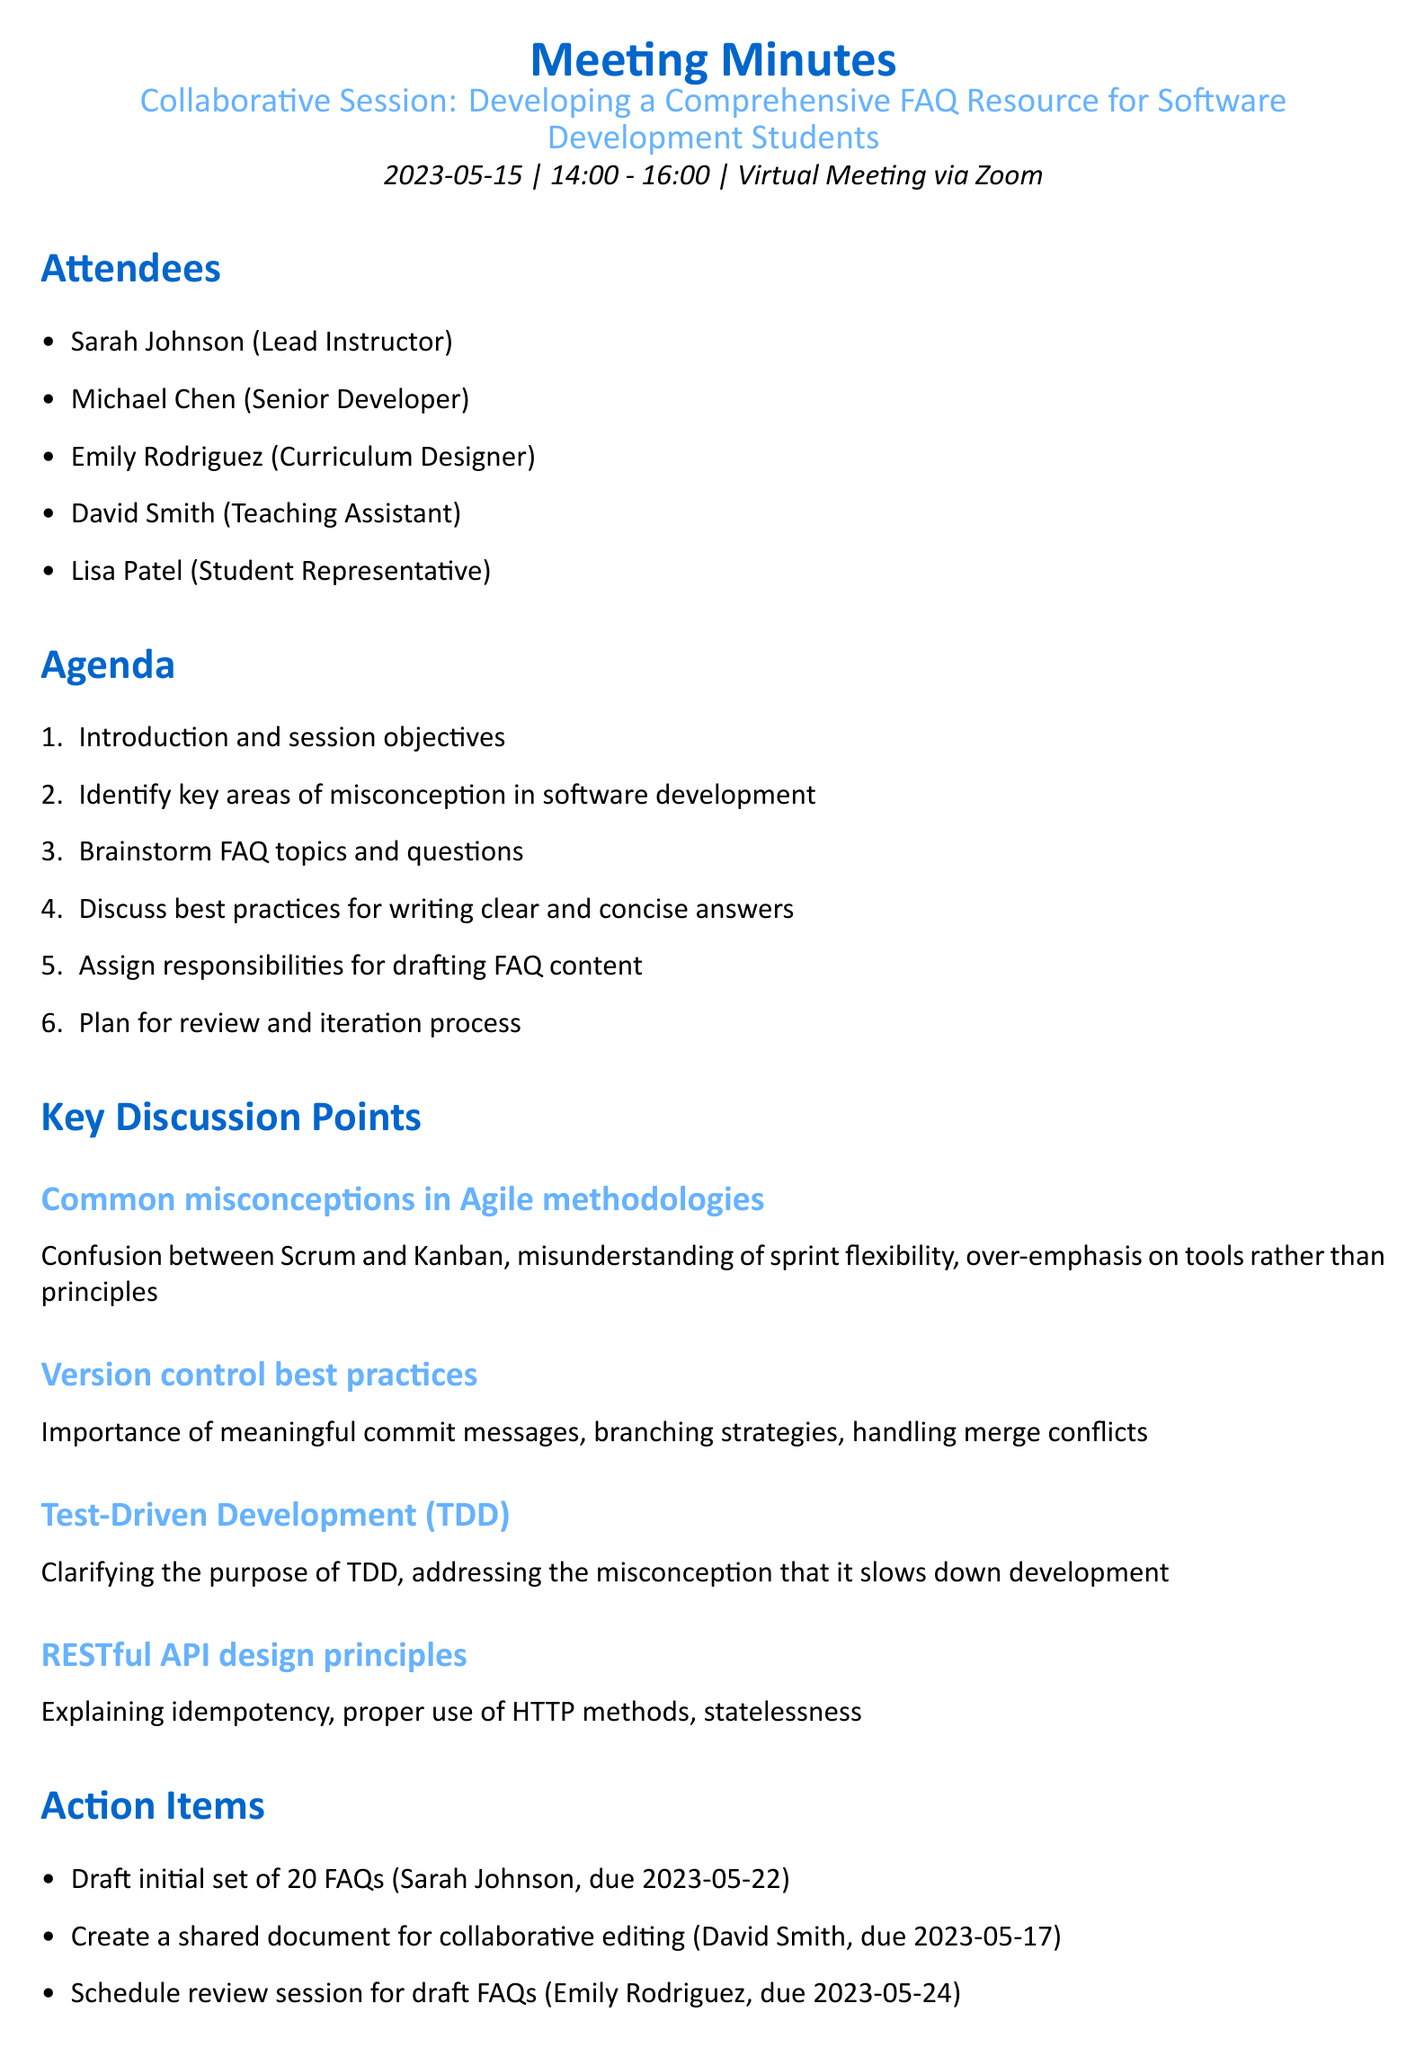What is the date of the meeting? The date of the meeting is specified in the meeting details section of the document.
Answer: 2023-05-15 Who is the Lead Instructor? The Lead Instructor's name is provided in the list of attendees.
Answer: Sarah Johnson What is one of the key discussion points about Agile methodologies? The document outlines key discussion points, including misconceptions about Agile methodologies.
Answer: Confusion between Scrum and Kanban What is the deadline for drafting the initial set of FAQs? The deadline is mentioned in the action items section next to the responsible person's name.
Answer: 2023-05-22 Who is responsible for creating the shared document for collaborative editing? The assignee for the task is listed in the action items section.
Answer: David Smith How long did the meeting last? The duration can be calculated by subtracting the start time from the end time provided in the meeting details.
Answer: 2 hours What is one next step after circulating the draft FAQs? Next steps are outlined in a specific section of the document.
Answer: Gather feedback from a wider group of students What methodology was mentioned as a common misconception? The document mentions specific methodology misconceptions in the key discussion points section.
Answer: Agile methodologies 